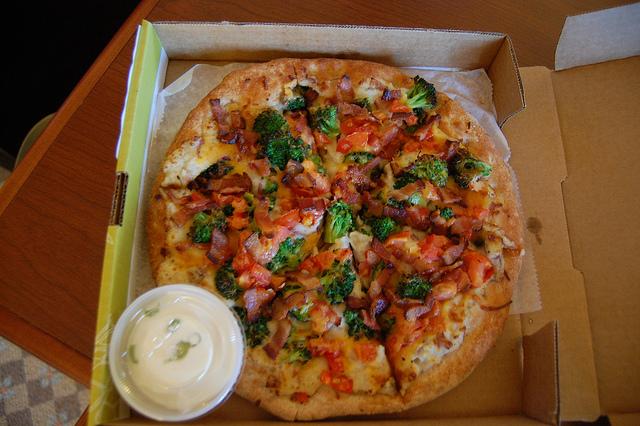Is the crust burned?
Give a very brief answer. No. Can you see a face in the pizza?
Write a very short answer. No. What is the pizza topped with?
Concise answer only. Broccoli. What is in the white cup?
Keep it brief. Sour cream. How many slices have been taken on the pizza?
Keep it brief. 0. Is There something green in the little cup?
Quick response, please. Yes. What is the pizza sitting on?
Give a very brief answer. Box. What is the green vegetable on the pizza?
Short answer required. Broccoli. 